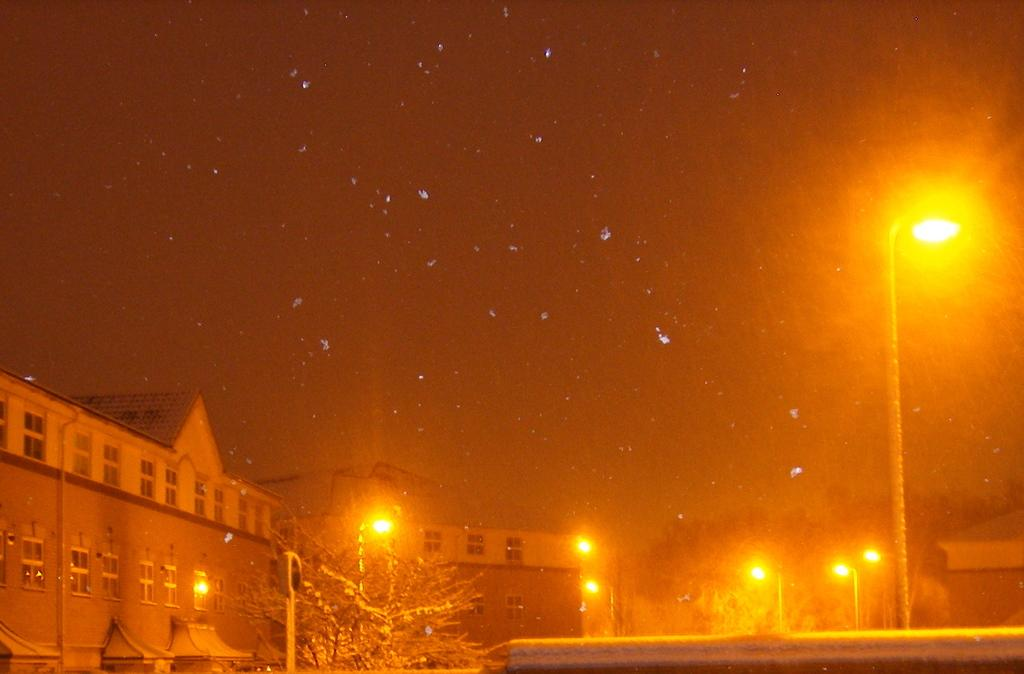What type of vegetation is at the bottom of the image? There are trees at the bottom of the image. What structure can be seen on the right side of the image? There is a light pole on the right side of the image. What is visible in the background of the image? The sky is visible in the background of the image. Can you see any grass growing on the light pole in the image? There is no grass growing on the light pole in the image. Is there a hat visible on the trees at the bottom of the image? There is no hat present in the image. 